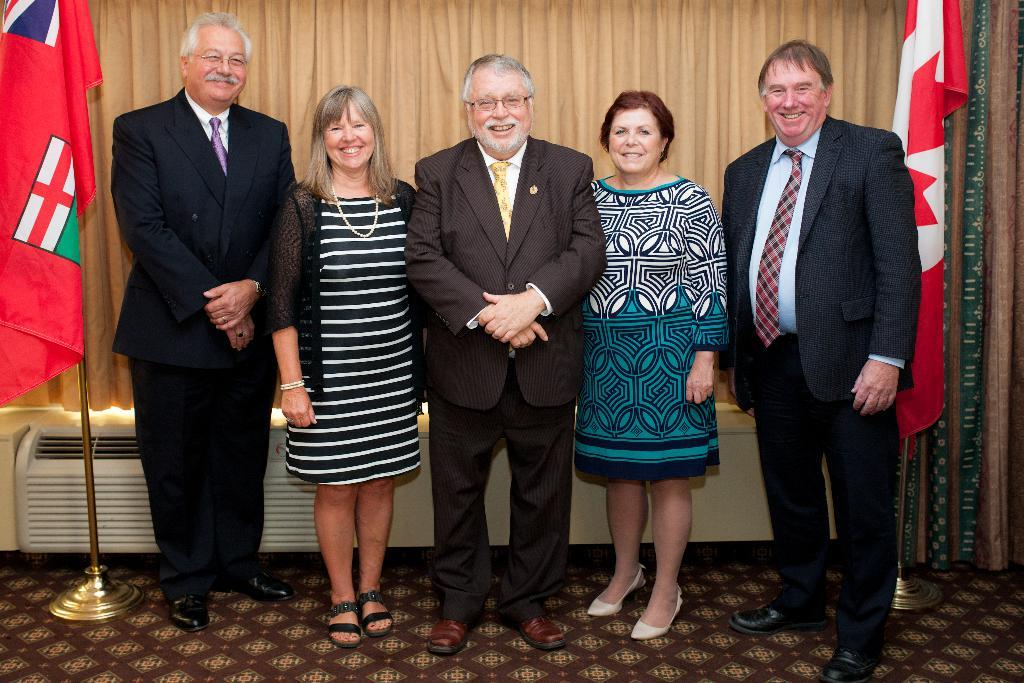How many people are standing together in the image? There is a group of five standing people in the image. What can be seen in the background behind the group of people? There is an object behind the group of people in the image. What is present in the image that might be used for decoration or privacy? There is a curtain in the image. How many flags are visible in the image? There are two flags in the image. What type of fish can be seen swimming near the group of people in the image? There are no fish present in the image; it features a group of people, a curtain, two flags, and an object behind the group. 